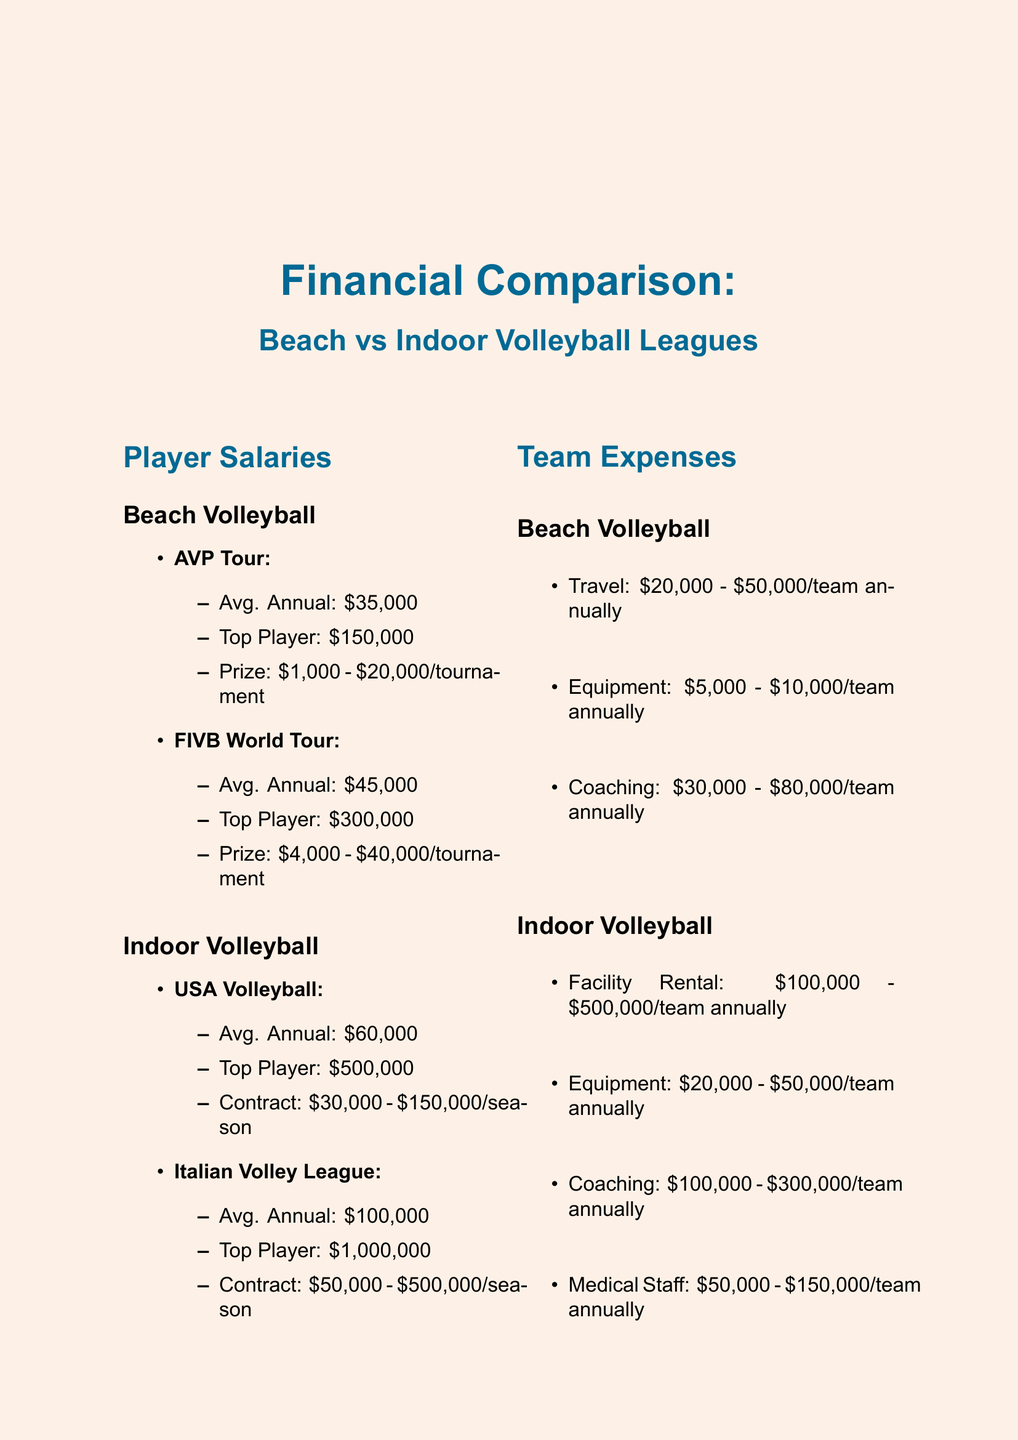what is the average annual salary for a player in the AVP Tour? The average annual salary for a player in the AVP Tour is provided directly in the document.
Answer: $35,000 what is the top player salary in the Italian Volley League? The document specifies the top player salary in the Italian Volley League.
Answer: $1,000,000 what are the travel costs for beach volleyball teams? The document lists the travel costs for beach volleyball teams as a specific range.
Answer: $20,000 - $50,000 per team annually how much does it cost to rent a facility for indoor volleyball teams? The document provides the cost range for facility rental for indoor volleyball teams.
Answer: $100,000 - $500,000 per team annually which league has the highest average annual salary for players? This question requires comparing the average annual salaries across the leagues presented in the document.
Answer: Italian Volley League what is the total annual revenue for beach volleyball leagues? The total annual revenue is calculated by summing the revenues from both beach volleyball leagues mentioned.
Answer: $25 million how many major sponsors are listed for the FIVB World Tour? The number of sponsors for the FIVB World Tour is counted directly from the information provided in the document.
Answer: 3 what additional expenses are mentioned for indoor volleyball teams that are not listed for beach volleyball teams? The question highlights specific categories of costs that are present for indoor teams but absent for beach teams as stated in the document.
Answer: Medical Staff in which league does a player earn an average salary of $60,000? The document identifies the specific league where this average salary applies.
Answer: USA Volleyball 